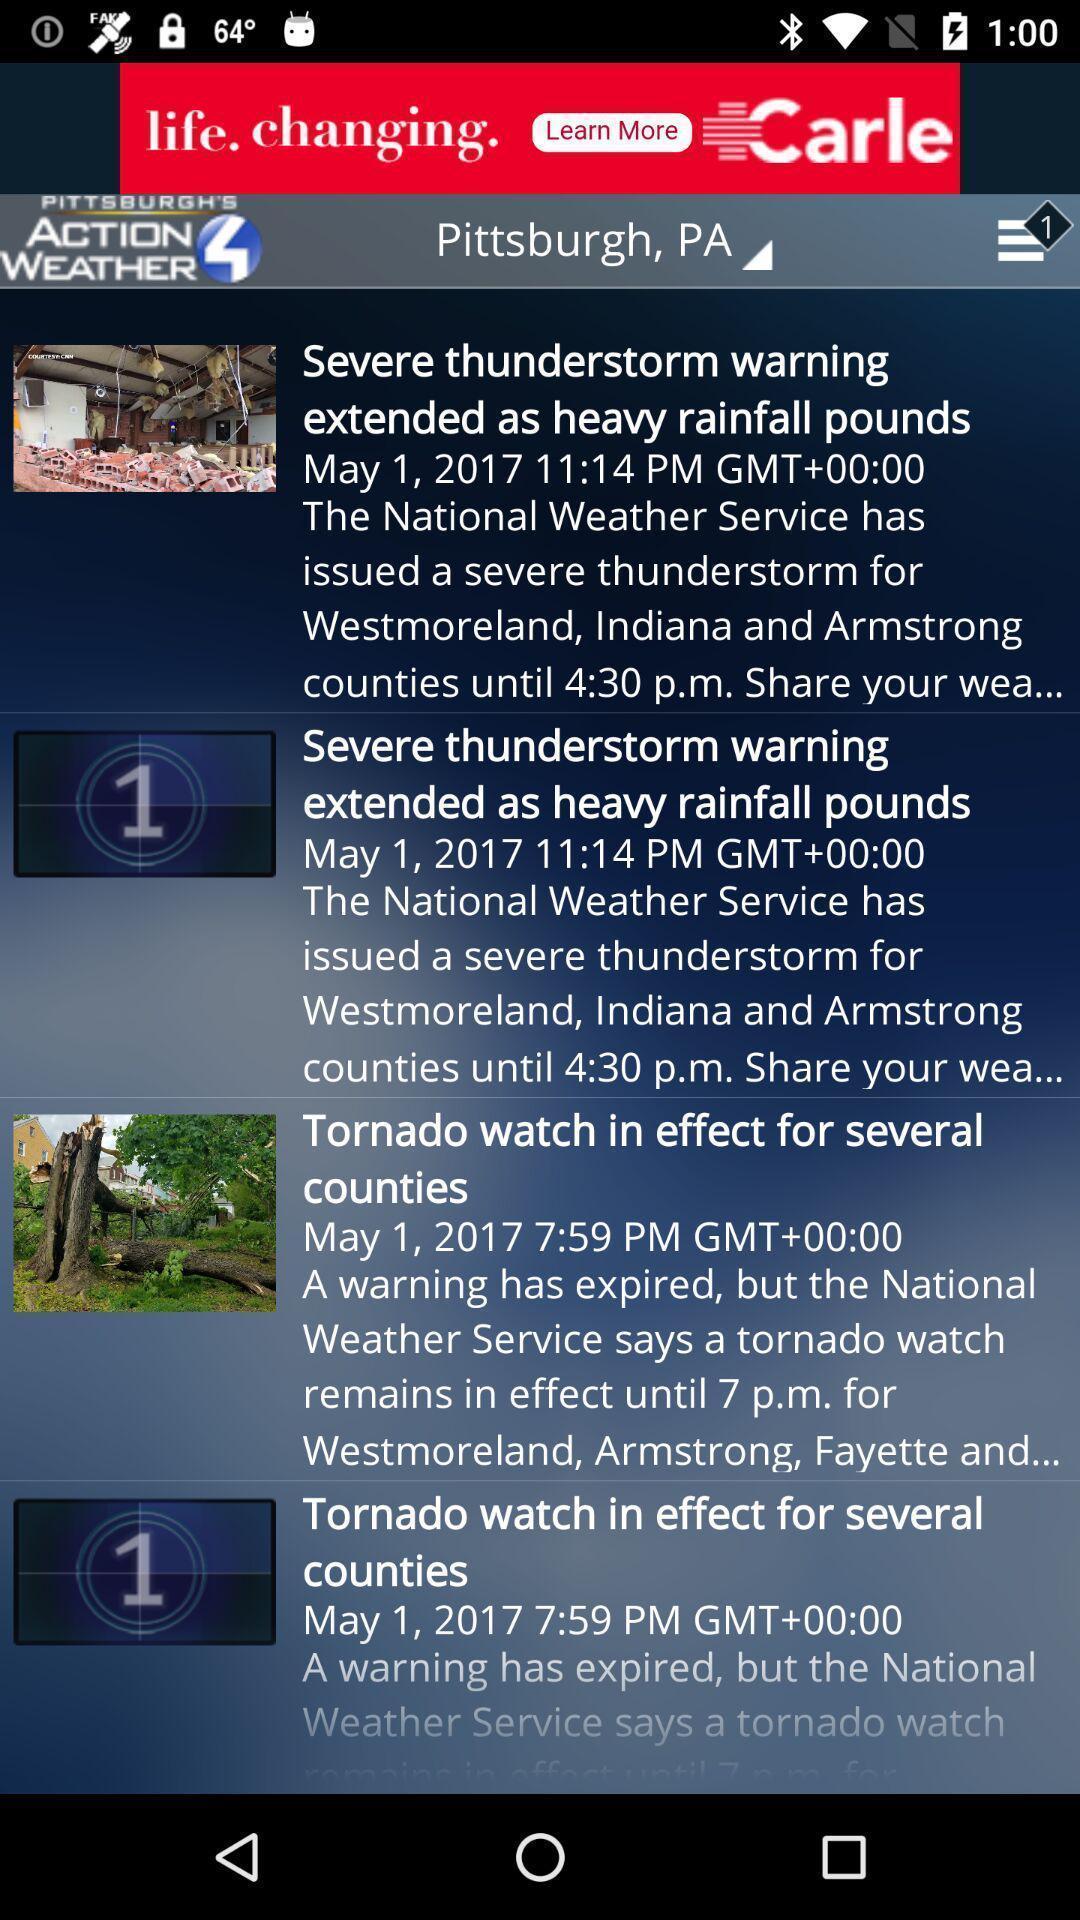Tell me about the visual elements in this screen capture. Page showing list of articles on a news app. 